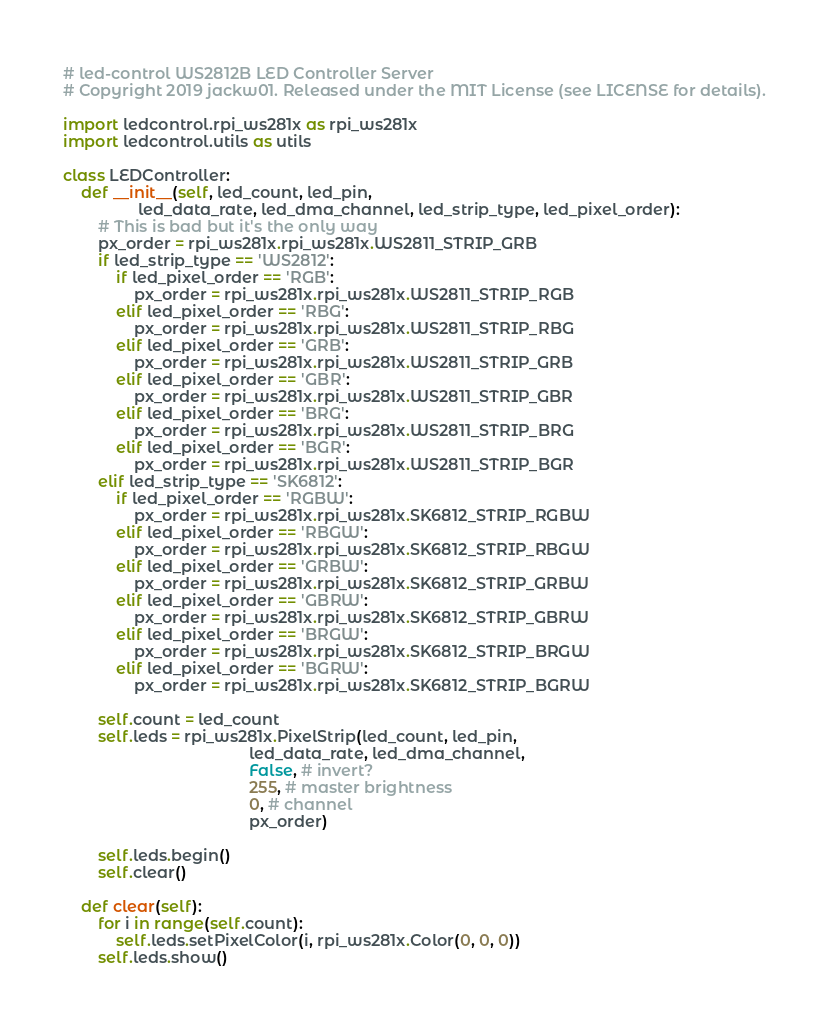Convert code to text. <code><loc_0><loc_0><loc_500><loc_500><_Python_># led-control WS2812B LED Controller Server
# Copyright 2019 jackw01. Released under the MIT License (see LICENSE for details).

import ledcontrol.rpi_ws281x as rpi_ws281x
import ledcontrol.utils as utils

class LEDController:
    def __init__(self, led_count, led_pin,
                 led_data_rate, led_dma_channel, led_strip_type, led_pixel_order):
        # This is bad but it's the only way
        px_order = rpi_ws281x.rpi_ws281x.WS2811_STRIP_GRB
        if led_strip_type == 'WS2812':
            if led_pixel_order == 'RGB':
                px_order = rpi_ws281x.rpi_ws281x.WS2811_STRIP_RGB
            elif led_pixel_order == 'RBG':
                px_order = rpi_ws281x.rpi_ws281x.WS2811_STRIP_RBG
            elif led_pixel_order == 'GRB':
                px_order = rpi_ws281x.rpi_ws281x.WS2811_STRIP_GRB
            elif led_pixel_order == 'GBR':
                px_order = rpi_ws281x.rpi_ws281x.WS2811_STRIP_GBR
            elif led_pixel_order == 'BRG':
                px_order = rpi_ws281x.rpi_ws281x.WS2811_STRIP_BRG
            elif led_pixel_order == 'BGR':
                px_order = rpi_ws281x.rpi_ws281x.WS2811_STRIP_BGR
        elif led_strip_type == 'SK6812':
            if led_pixel_order == 'RGBW':
                px_order = rpi_ws281x.rpi_ws281x.SK6812_STRIP_RGBW
            elif led_pixel_order == 'RBGW':
                px_order = rpi_ws281x.rpi_ws281x.SK6812_STRIP_RBGW
            elif led_pixel_order == 'GRBW':
                px_order = rpi_ws281x.rpi_ws281x.SK6812_STRIP_GRBW
            elif led_pixel_order == 'GBRW':
                px_order = rpi_ws281x.rpi_ws281x.SK6812_STRIP_GBRW
            elif led_pixel_order == 'BRGW':
                px_order = rpi_ws281x.rpi_ws281x.SK6812_STRIP_BRGW
            elif led_pixel_order == 'BGRW':
                px_order = rpi_ws281x.rpi_ws281x.SK6812_STRIP_BGRW

        self.count = led_count
        self.leds = rpi_ws281x.PixelStrip(led_count, led_pin,
                                          led_data_rate, led_dma_channel,
                                          False, # invert?
                                          255, # master brightness
                                          0, # channel
                                          px_order)

        self.leds.begin()
        self.clear()

    def clear(self):
        for i in range(self.count):
            self.leds.setPixelColor(i, rpi_ws281x.Color(0, 0, 0))
        self.leds.show()
</code> 